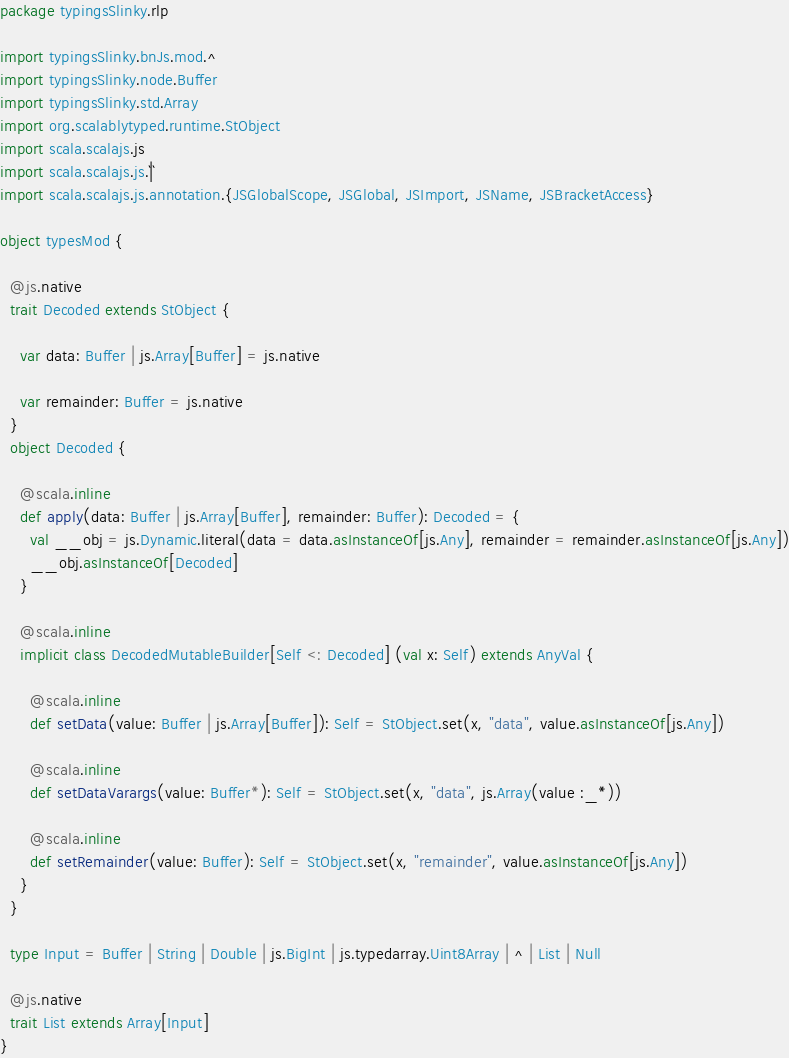Convert code to text. <code><loc_0><loc_0><loc_500><loc_500><_Scala_>package typingsSlinky.rlp

import typingsSlinky.bnJs.mod.^
import typingsSlinky.node.Buffer
import typingsSlinky.std.Array
import org.scalablytyped.runtime.StObject
import scala.scalajs.js
import scala.scalajs.js.`|`
import scala.scalajs.js.annotation.{JSGlobalScope, JSGlobal, JSImport, JSName, JSBracketAccess}

object typesMod {
  
  @js.native
  trait Decoded extends StObject {
    
    var data: Buffer | js.Array[Buffer] = js.native
    
    var remainder: Buffer = js.native
  }
  object Decoded {
    
    @scala.inline
    def apply(data: Buffer | js.Array[Buffer], remainder: Buffer): Decoded = {
      val __obj = js.Dynamic.literal(data = data.asInstanceOf[js.Any], remainder = remainder.asInstanceOf[js.Any])
      __obj.asInstanceOf[Decoded]
    }
    
    @scala.inline
    implicit class DecodedMutableBuilder[Self <: Decoded] (val x: Self) extends AnyVal {
      
      @scala.inline
      def setData(value: Buffer | js.Array[Buffer]): Self = StObject.set(x, "data", value.asInstanceOf[js.Any])
      
      @scala.inline
      def setDataVarargs(value: Buffer*): Self = StObject.set(x, "data", js.Array(value :_*))
      
      @scala.inline
      def setRemainder(value: Buffer): Self = StObject.set(x, "remainder", value.asInstanceOf[js.Any])
    }
  }
  
  type Input = Buffer | String | Double | js.BigInt | js.typedarray.Uint8Array | ^ | List | Null
  
  @js.native
  trait List extends Array[Input]
}
</code> 